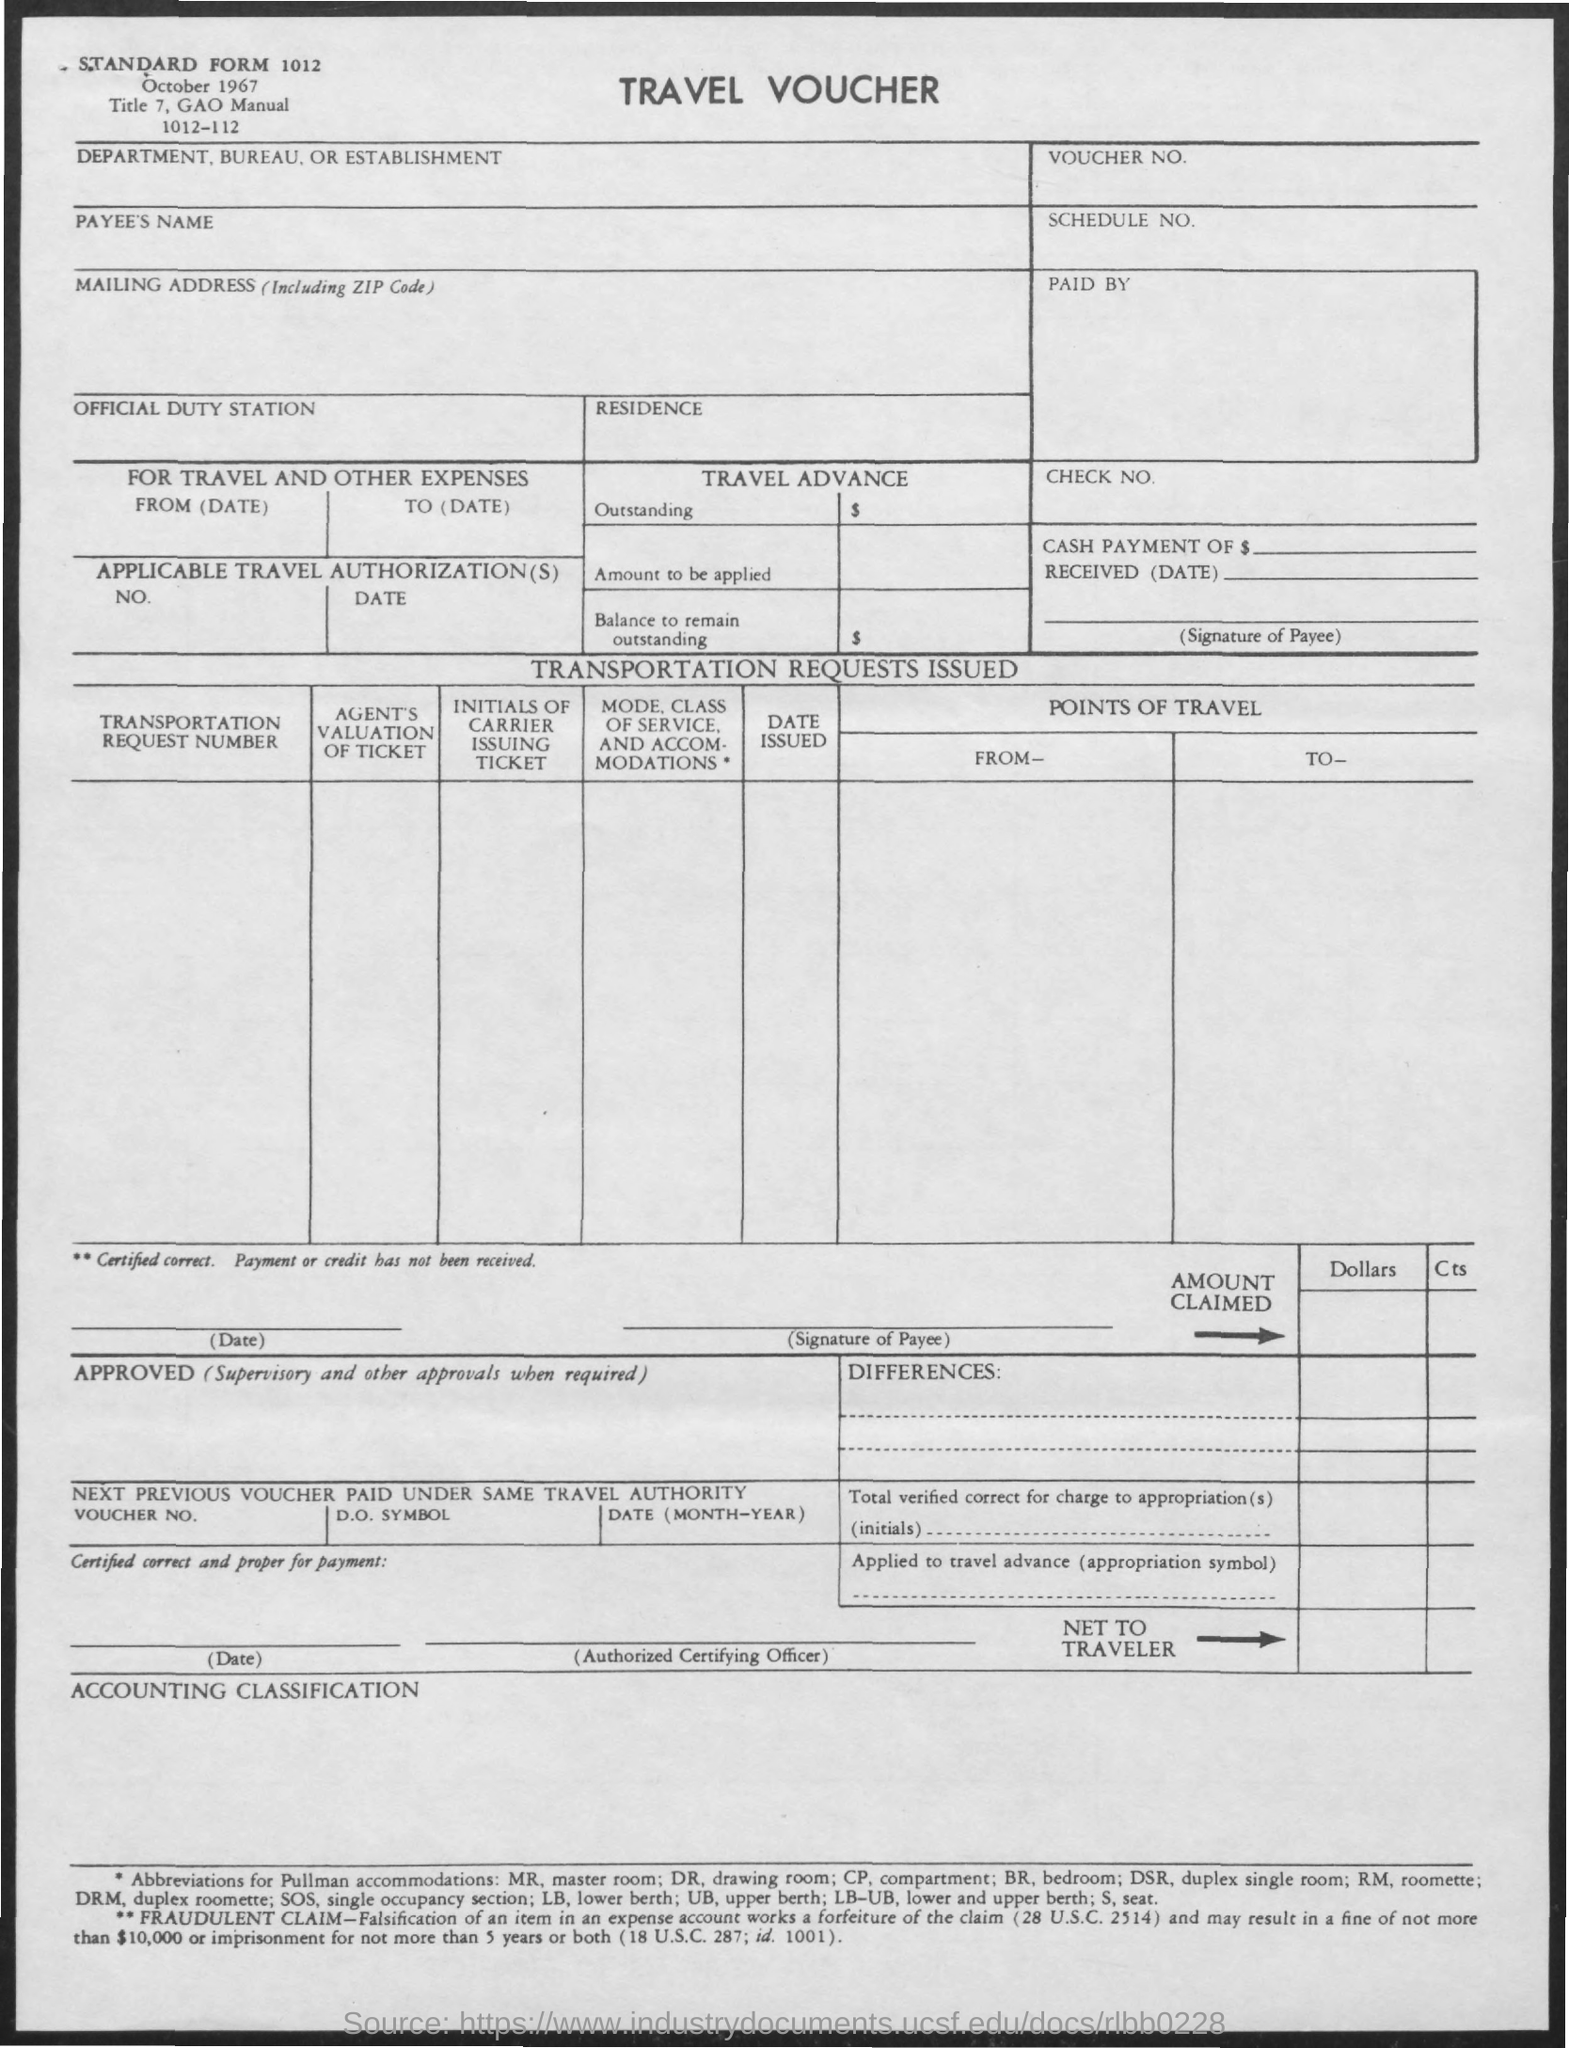What is the Standard Form No. given in the travel voucher?
Your answer should be compact. 1012. What type of voucher is given here?
Offer a very short reply. TRAVEL VOUCHER. 